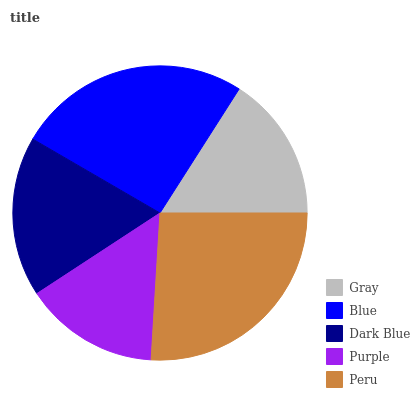Is Purple the minimum?
Answer yes or no. Yes. Is Peru the maximum?
Answer yes or no. Yes. Is Blue the minimum?
Answer yes or no. No. Is Blue the maximum?
Answer yes or no. No. Is Blue greater than Gray?
Answer yes or no. Yes. Is Gray less than Blue?
Answer yes or no. Yes. Is Gray greater than Blue?
Answer yes or no. No. Is Blue less than Gray?
Answer yes or no. No. Is Dark Blue the high median?
Answer yes or no. Yes. Is Dark Blue the low median?
Answer yes or no. Yes. Is Purple the high median?
Answer yes or no. No. Is Peru the low median?
Answer yes or no. No. 